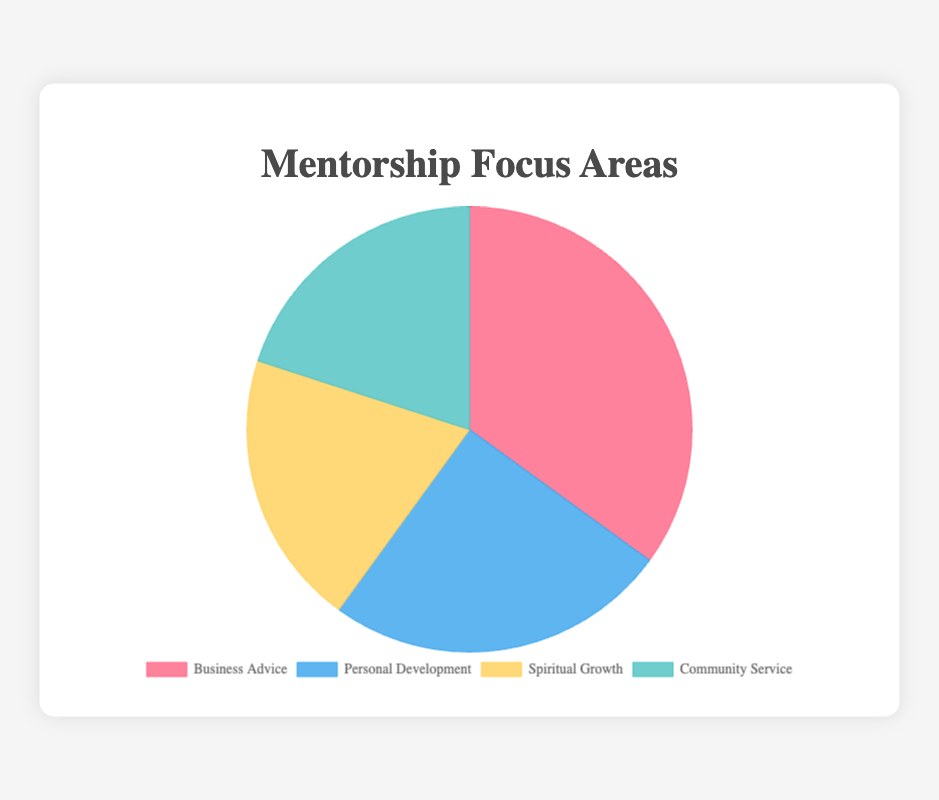What is the largest mentorship focus area by percentage? The pie chart shows that "Business Advice" occupies the largest segment, accounting for 35% of the total mentorship focus areas.
Answer: Business Advice Which two focus areas have the same percentage? The pie chart illustrates that "Spiritual Growth" and "Community Service" each occupy 20% of the total mentorship focus areas.
Answer: Spiritual Growth and Community Service What is the total percentage of the two smallest mentorship focus areas combined? According to the pie chart, "Spiritual Growth" is 20% and "Community Service" is also 20%. Adding these together, 20% + 20% equals 40%.
Answer: 40% Which focus area is represented by the blue segment? The pie chart uses blue to represent "Personal Development," which occupies 25% of the total focus areas.
Answer: Personal Development By what percentage does "Business Advice" exceed "Spiritual Growth"? "Business Advice" is 35% and "Spiritual Growth" is 20%. Subtracting these, 35% - 20% equals 15%.
Answer: 15% Is "Community Service" larger or smaller than "Personal Development"? By how much? The pie chart shows "Community Service" at 20% and "Personal Development" at 25%. Subtracting these, 25% - 20% equals 5%. Hence, "Community Service" is smaller by 5%.
Answer: Smaller, by 5% What is the average percentage of the four mentorship focus areas? The percentages for the four areas are 35%, 25%, 20%, and 20%. Adding these, 35 + 25 + 20 + 20 equals 100. Dividing by 4, 100 / 4 equals 25%.
Answer: 25% What is the total percentage of "Business Advice" and "Personal Development" combined? "Business Advice" is 35% and "Personal Development" is 25%. Adding these together, 35% + 25% equals 60%.
Answer: 60% Which focus area has the second largest percentage? The second largest segment in the pie chart is the blue one, representing "Personal Development" at 25%.
Answer: Personal Development If you sum the percentages of "Business Advice" and "Community Service", what fraction of the pie chart do they represent? "Business Advice" is 35% and "Community Service" is 20%. Adding these together, 35% + 20% equals 55%. The fraction of the pie chart they represent is 55/100, simplifying to 11/20.
Answer: 11/20 